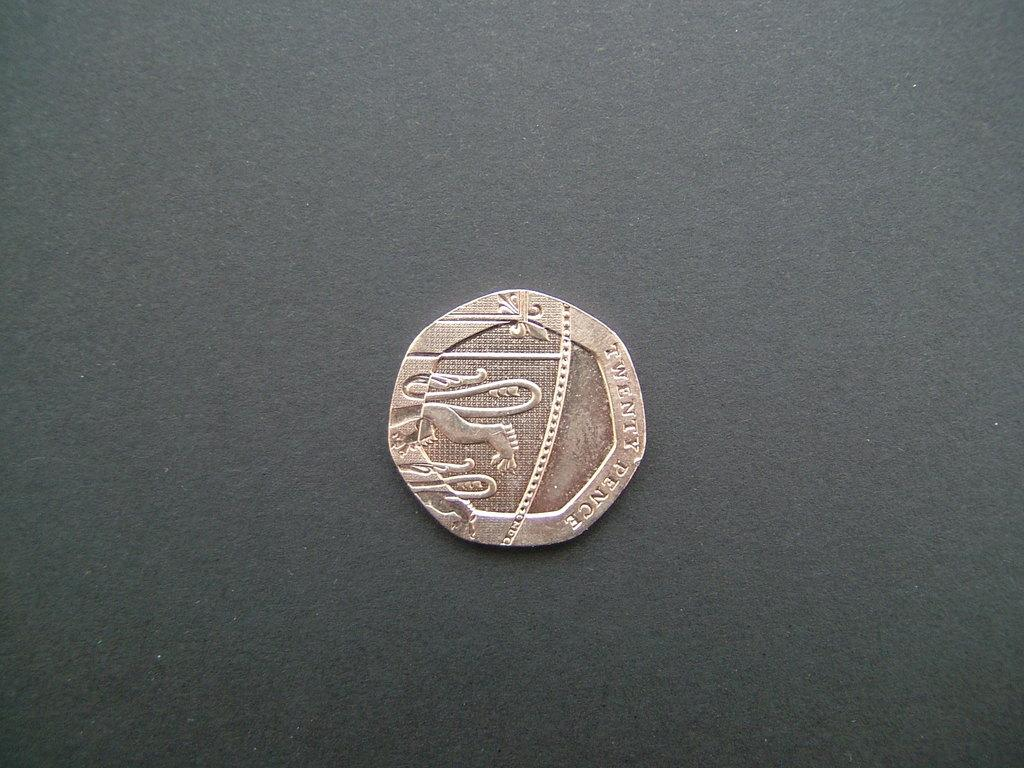<image>
Share a concise interpretation of the image provided. A small twenty pence coin with an illustration etched on it. 